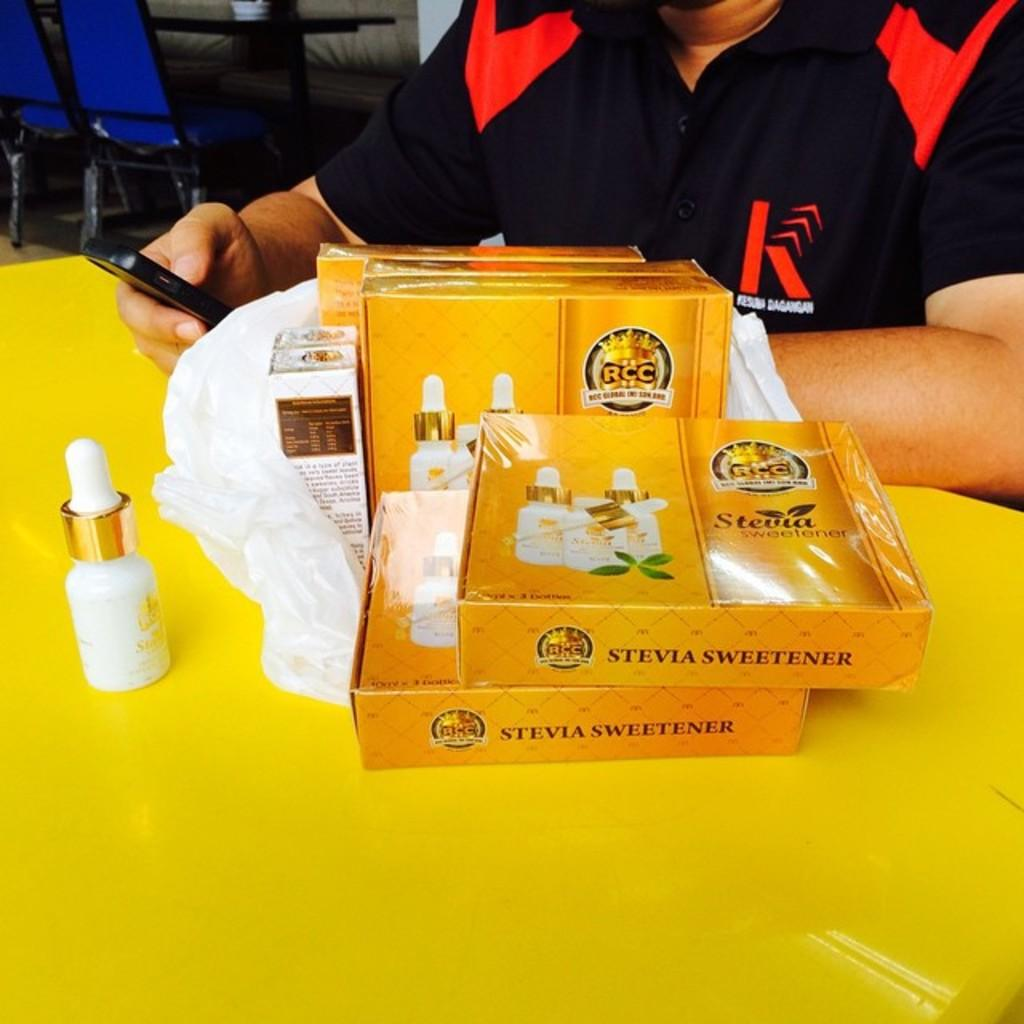<image>
Describe the image concisely. Packages of Stevia are displayed on a yellow table in front of a person wearing a black and red shirt. 